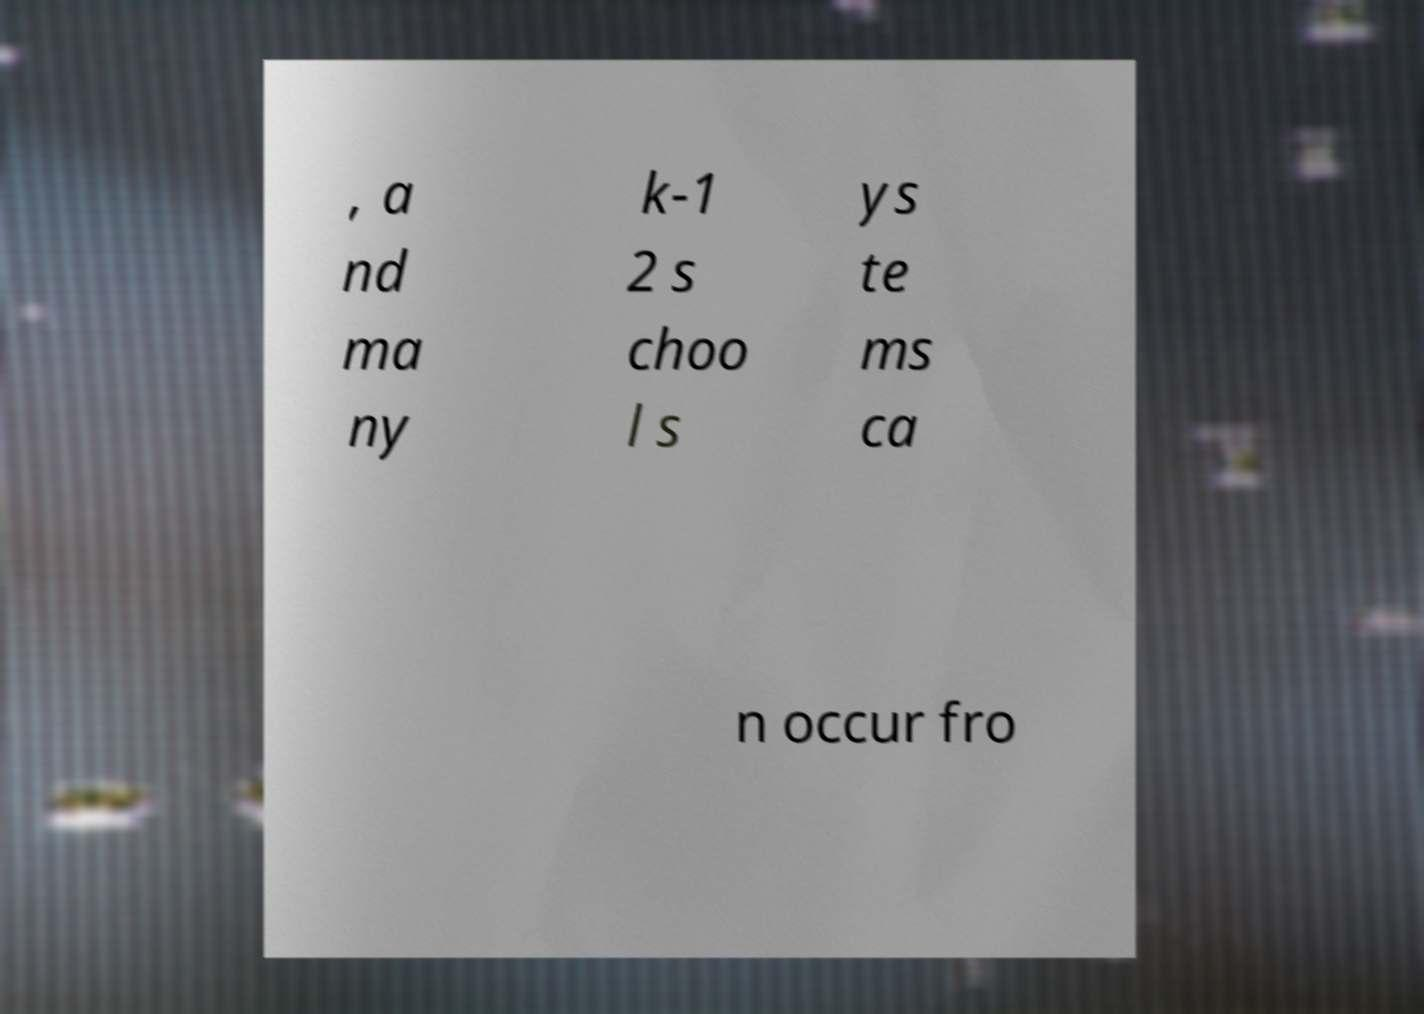Can you read and provide the text displayed in the image?This photo seems to have some interesting text. Can you extract and type it out for me? , a nd ma ny k-1 2 s choo l s ys te ms ca n occur fro 